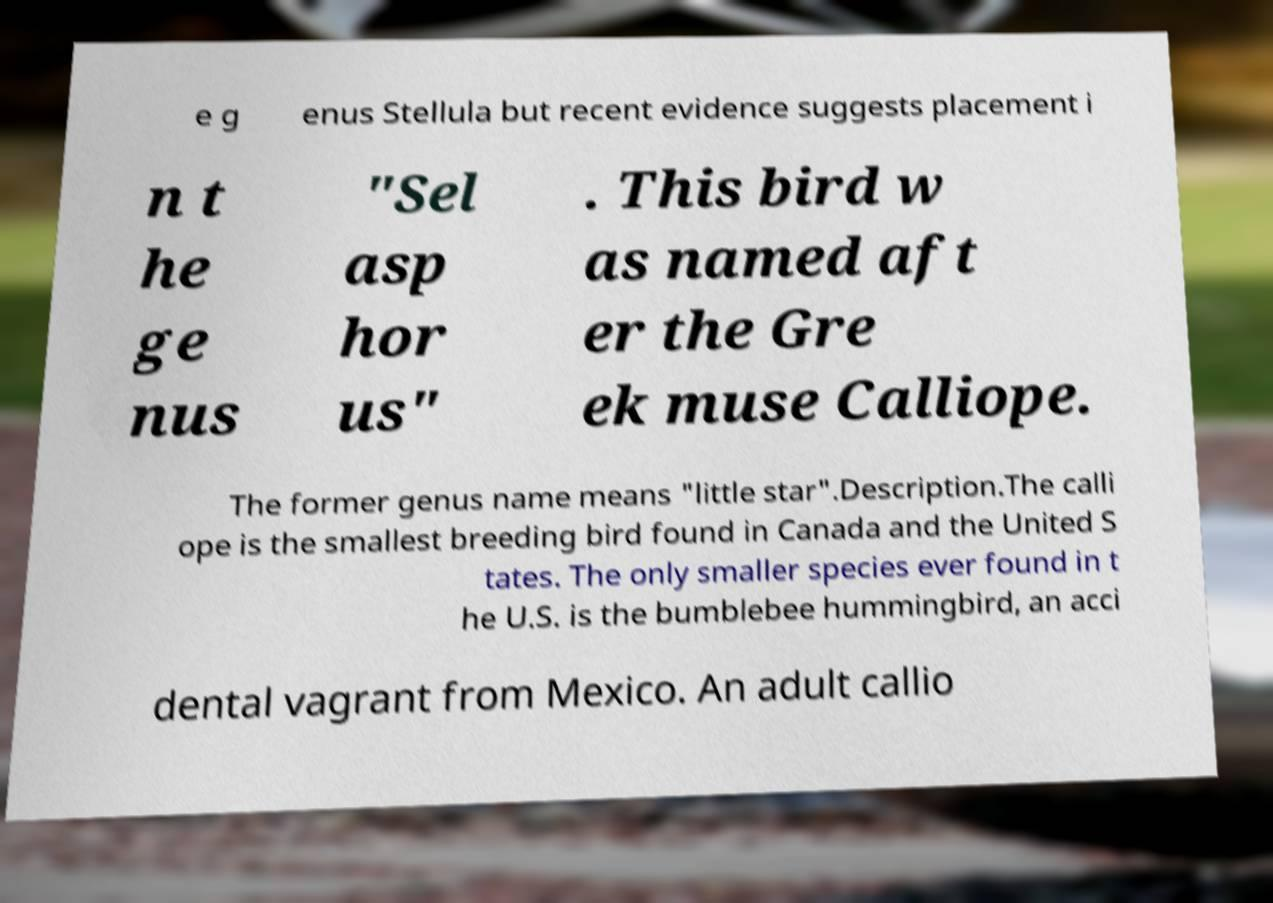Can you read and provide the text displayed in the image?This photo seems to have some interesting text. Can you extract and type it out for me? e g enus Stellula but recent evidence suggests placement i n t he ge nus "Sel asp hor us" . This bird w as named aft er the Gre ek muse Calliope. The former genus name means "little star".Description.The calli ope is the smallest breeding bird found in Canada and the United S tates. The only smaller species ever found in t he U.S. is the bumblebee hummingbird, an acci dental vagrant from Mexico. An adult callio 